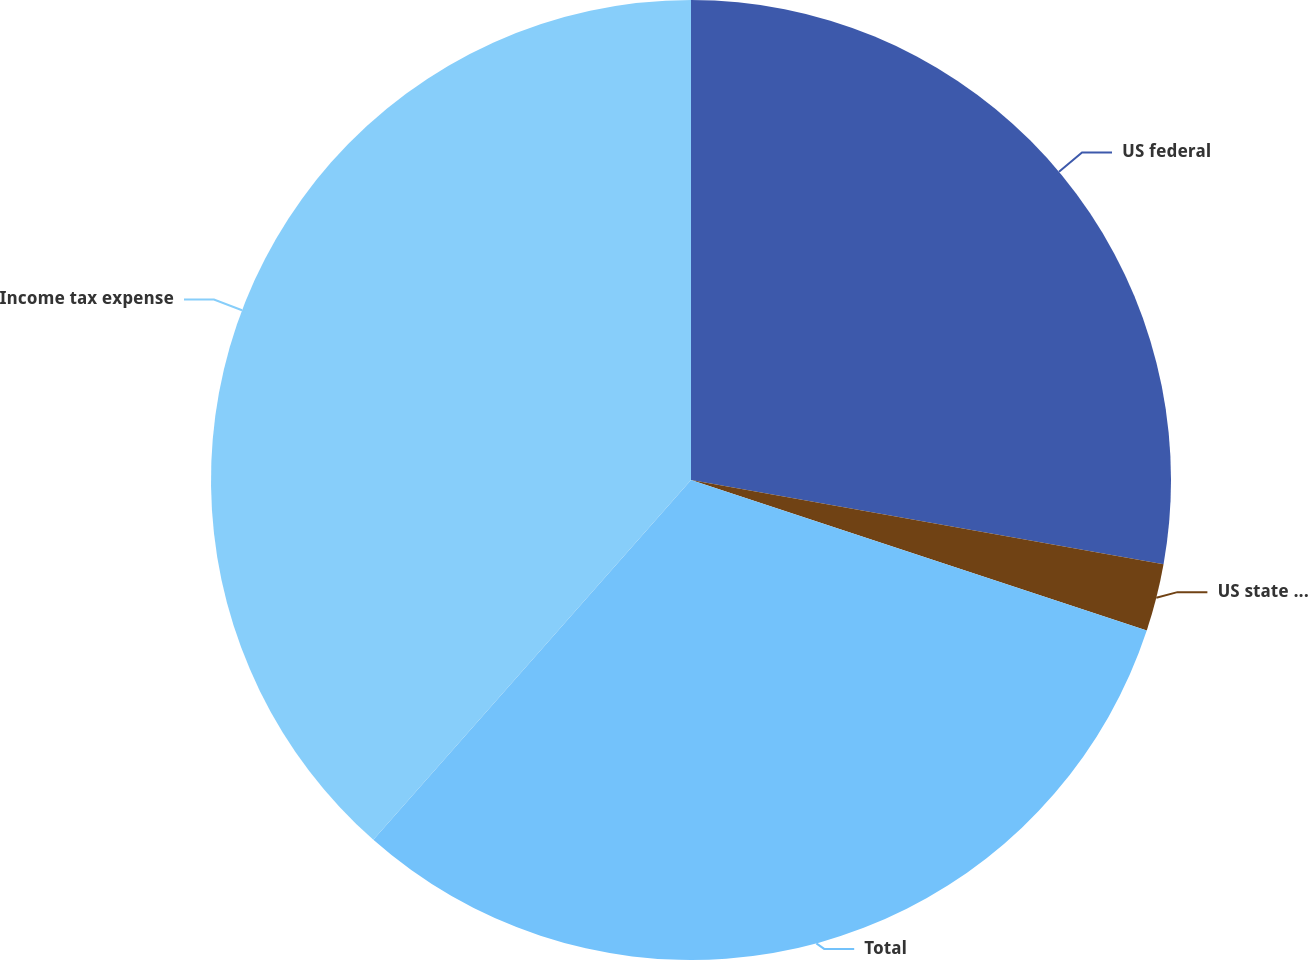Convert chart to OTSL. <chart><loc_0><loc_0><loc_500><loc_500><pie_chart><fcel>US federal<fcel>US state and local<fcel>Total<fcel>Income tax expense<nl><fcel>27.81%<fcel>2.27%<fcel>31.43%<fcel>38.49%<nl></chart> 